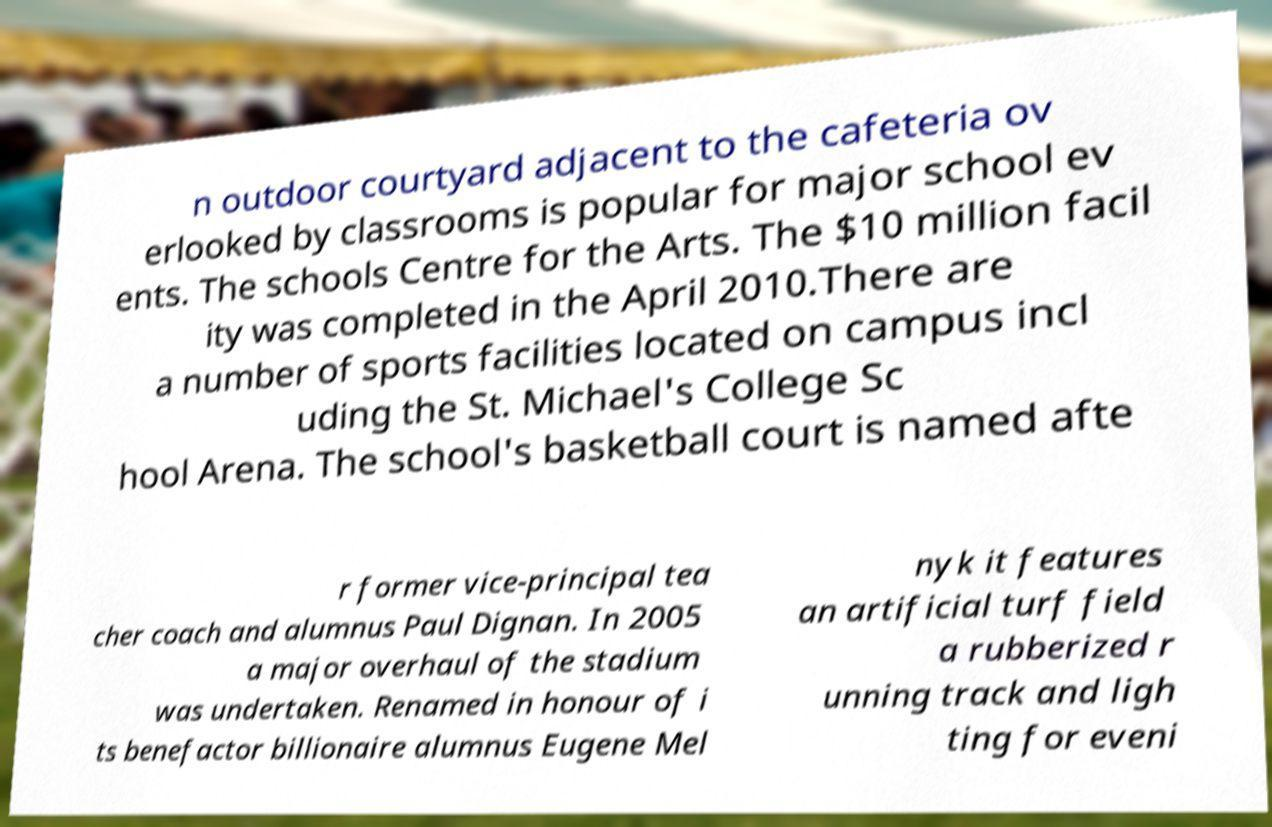What messages or text are displayed in this image? I need them in a readable, typed format. n outdoor courtyard adjacent to the cafeteria ov erlooked by classrooms is popular for major school ev ents. The schools Centre for the Arts. The $10 million facil ity was completed in the April 2010.There are a number of sports facilities located on campus incl uding the St. Michael's College Sc hool Arena. The school's basketball court is named afte r former vice-principal tea cher coach and alumnus Paul Dignan. In 2005 a major overhaul of the stadium was undertaken. Renamed in honour of i ts benefactor billionaire alumnus Eugene Mel nyk it features an artificial turf field a rubberized r unning track and ligh ting for eveni 